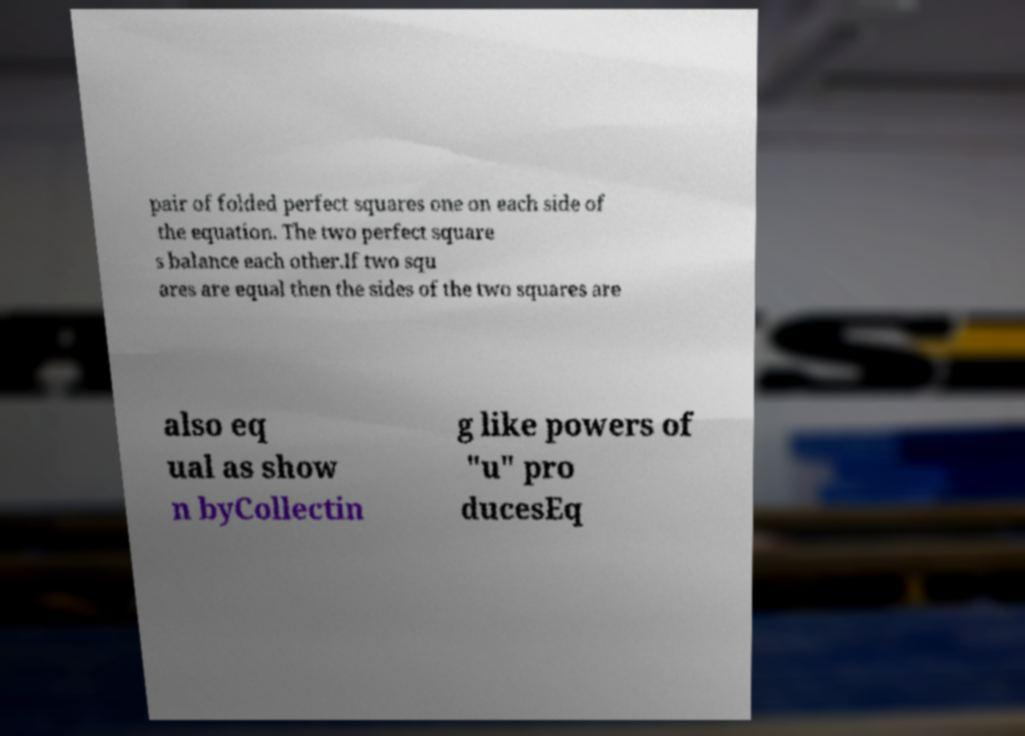Please read and relay the text visible in this image. What does it say? pair of folded perfect squares one on each side of the equation. The two perfect square s balance each other.If two squ ares are equal then the sides of the two squares are also eq ual as show n byCollectin g like powers of "u" pro ducesEq 